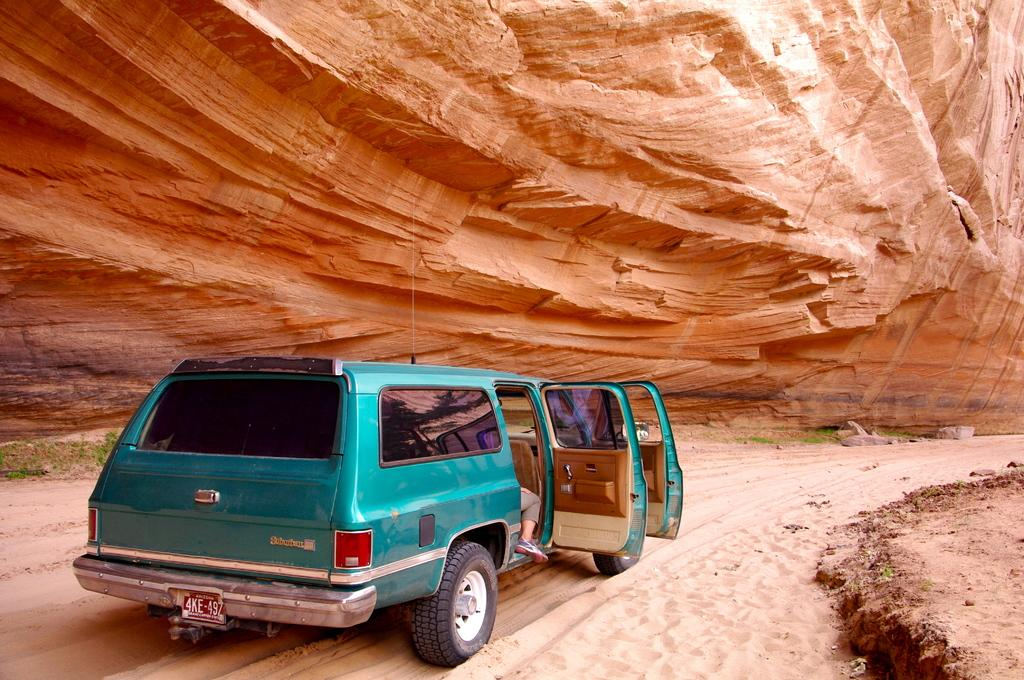What type of terrain is visible in the image? There is sand on the ground in the image. What vehicle is present in the image? There is a car in the image. What geographical feature can be seen in the background of the image? There is a mountain in the image. Where is the shop located in the image? There is no shop present in the image. What type of cattle can be seen grazing near the car? There are no cattle present in the image. 